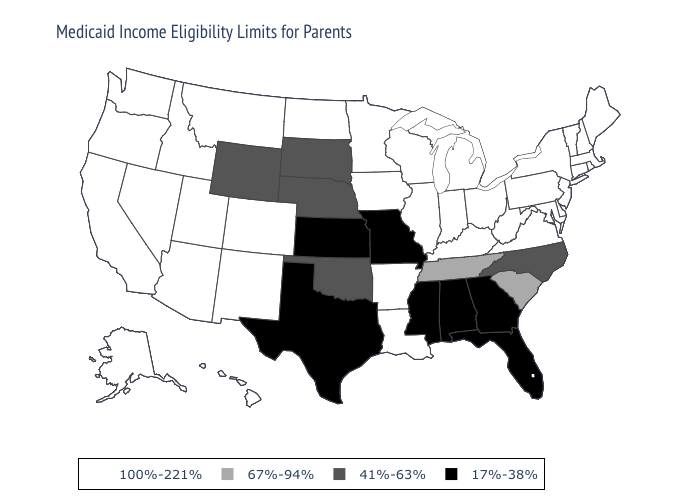Which states hav the highest value in the Northeast?
Quick response, please. Connecticut, Maine, Massachusetts, New Hampshire, New Jersey, New York, Pennsylvania, Rhode Island, Vermont. Which states hav the highest value in the South?
Concise answer only. Arkansas, Delaware, Kentucky, Louisiana, Maryland, Virginia, West Virginia. Does Nevada have the highest value in the USA?
Write a very short answer. Yes. Does Wyoming have the highest value in the USA?
Write a very short answer. No. Name the states that have a value in the range 100%-221%?
Be succinct. Alaska, Arizona, Arkansas, California, Colorado, Connecticut, Delaware, Hawaii, Idaho, Illinois, Indiana, Iowa, Kentucky, Louisiana, Maine, Maryland, Massachusetts, Michigan, Minnesota, Montana, Nevada, New Hampshire, New Jersey, New Mexico, New York, North Dakota, Ohio, Oregon, Pennsylvania, Rhode Island, Utah, Vermont, Virginia, Washington, West Virginia, Wisconsin. Name the states that have a value in the range 67%-94%?
Be succinct. South Carolina, Tennessee. How many symbols are there in the legend?
Write a very short answer. 4. Name the states that have a value in the range 17%-38%?
Quick response, please. Alabama, Florida, Georgia, Kansas, Mississippi, Missouri, Texas. Which states have the lowest value in the USA?
Concise answer only. Alabama, Florida, Georgia, Kansas, Mississippi, Missouri, Texas. Name the states that have a value in the range 67%-94%?
Answer briefly. South Carolina, Tennessee. What is the value of Arkansas?
Quick response, please. 100%-221%. Does Iowa have the same value as Mississippi?
Short answer required. No. Which states have the lowest value in the USA?
Give a very brief answer. Alabama, Florida, Georgia, Kansas, Mississippi, Missouri, Texas. Name the states that have a value in the range 67%-94%?
Answer briefly. South Carolina, Tennessee. Name the states that have a value in the range 17%-38%?
Write a very short answer. Alabama, Florida, Georgia, Kansas, Mississippi, Missouri, Texas. 